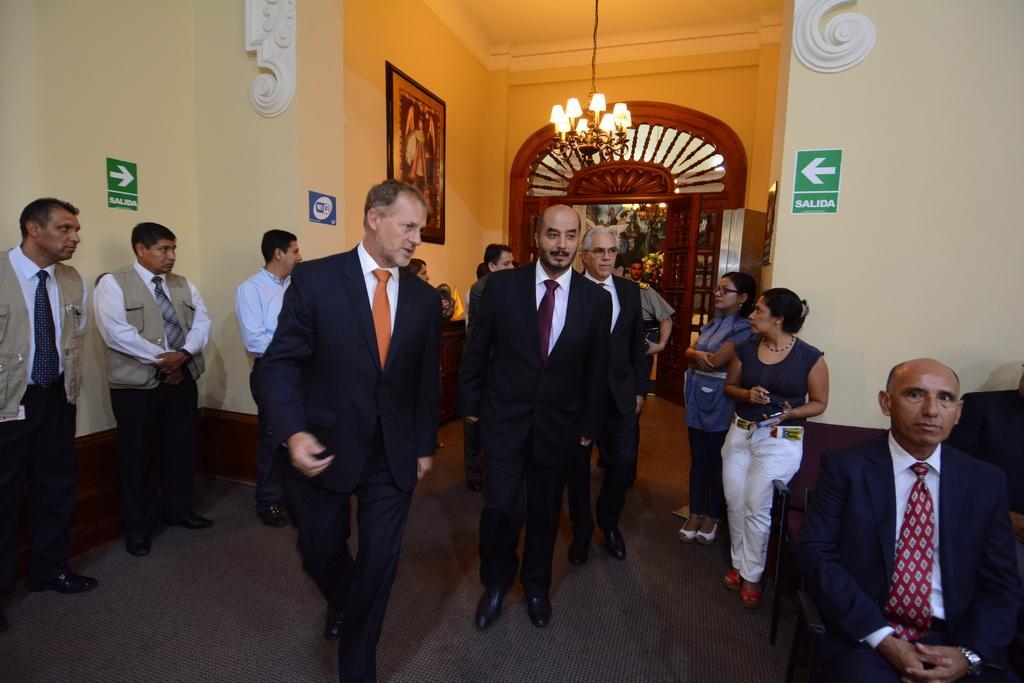Can you describe this image briefly? In the middle of the image few people are standing and walking. In the bottom right corner of the image a person is sitting. At the top of the image there is a wall and roof, on the wall there are some sign boards and frames and there is a door. 